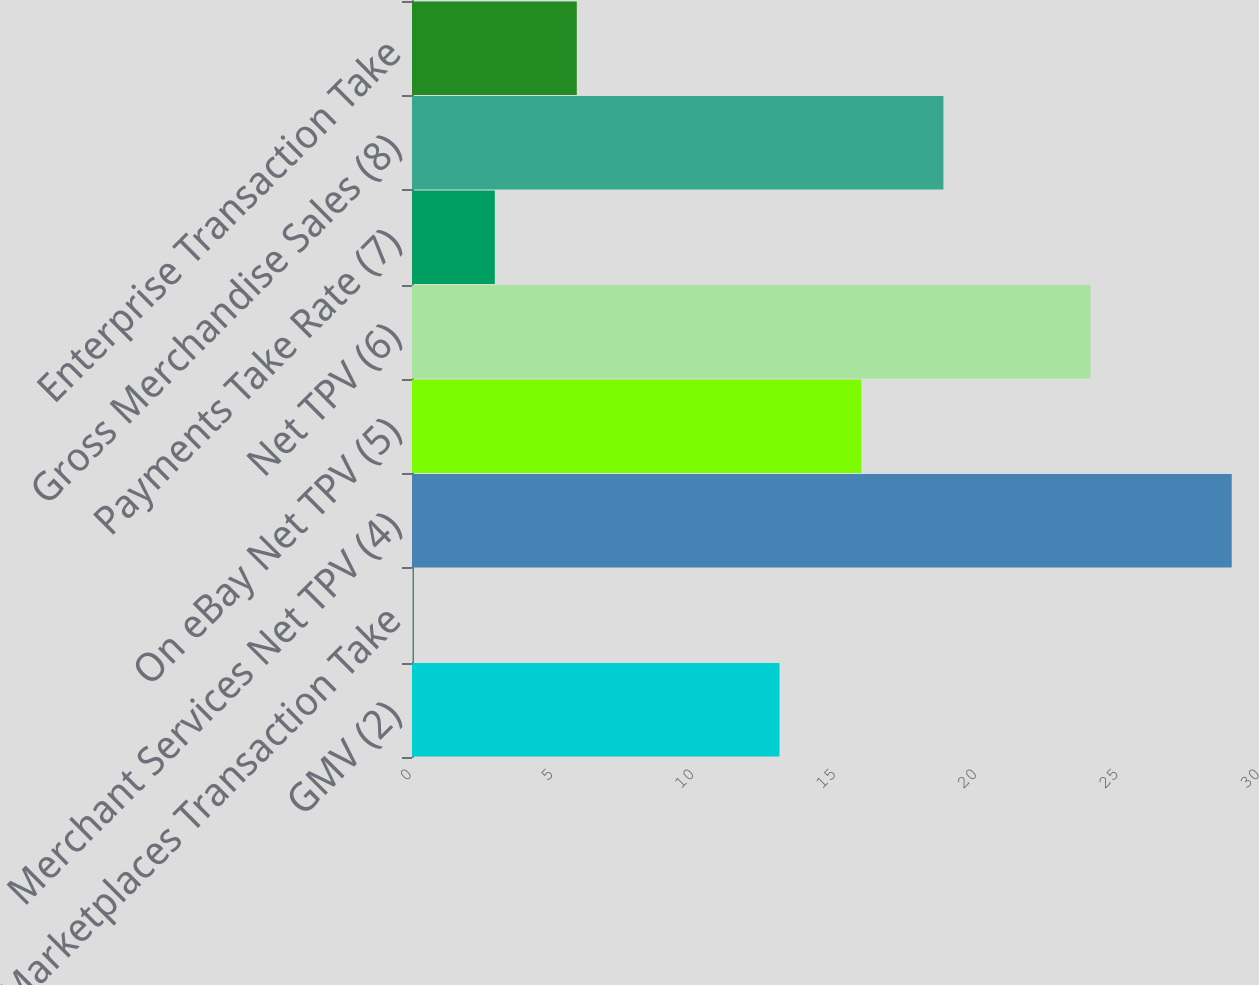Convert chart. <chart><loc_0><loc_0><loc_500><loc_500><bar_chart><fcel>GMV (2)<fcel>Marketplaces Transaction Take<fcel>Merchant Services Net TPV (4)<fcel>On eBay Net TPV (5)<fcel>Net TPV (6)<fcel>Payments Take Rate (7)<fcel>Gross Merchandise Sales (8)<fcel>Enterprise Transaction Take<nl><fcel>13<fcel>0.03<fcel>29<fcel>15.9<fcel>24<fcel>2.93<fcel>18.8<fcel>5.83<nl></chart> 